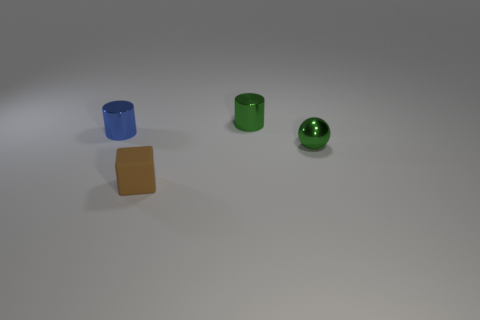Add 4 matte blocks. How many objects exist? 8 Subtract all blocks. How many objects are left? 3 Subtract all blue cylinders. Subtract all small yellow shiny blocks. How many objects are left? 3 Add 1 tiny green metal cylinders. How many tiny green metal cylinders are left? 2 Add 1 small things. How many small things exist? 5 Subtract 0 yellow cylinders. How many objects are left? 4 